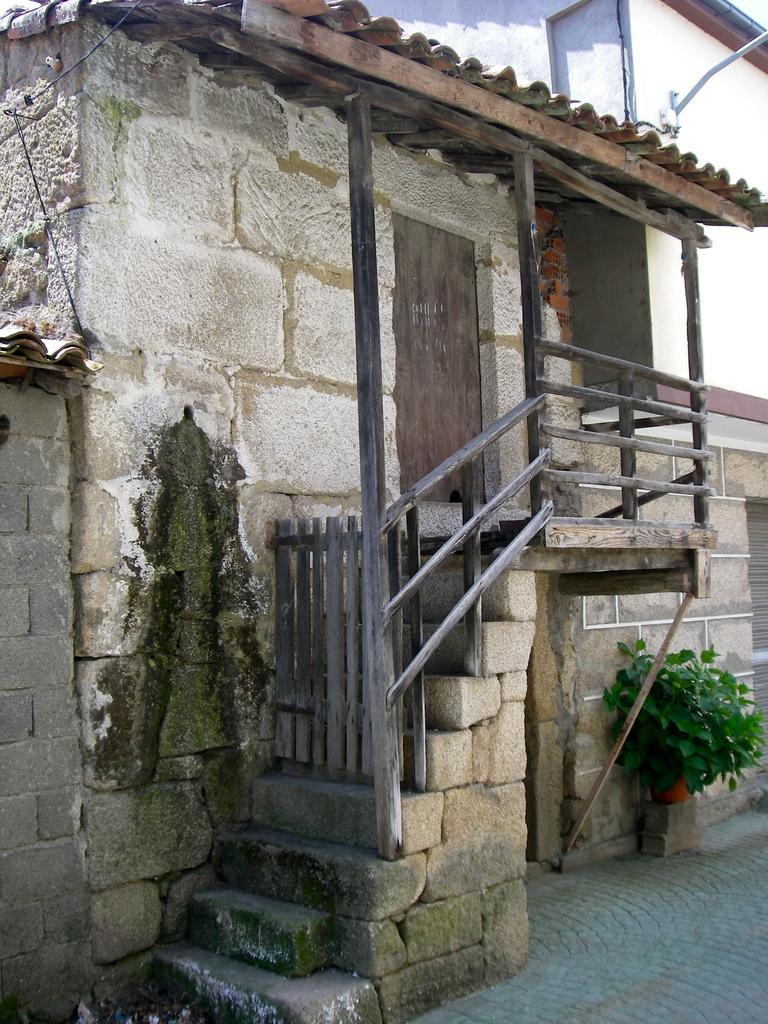How would you summarize this image in a sentence or two? In this image I can see in the middle there is the staircase and it looks like a house. On the right side there are plants. 